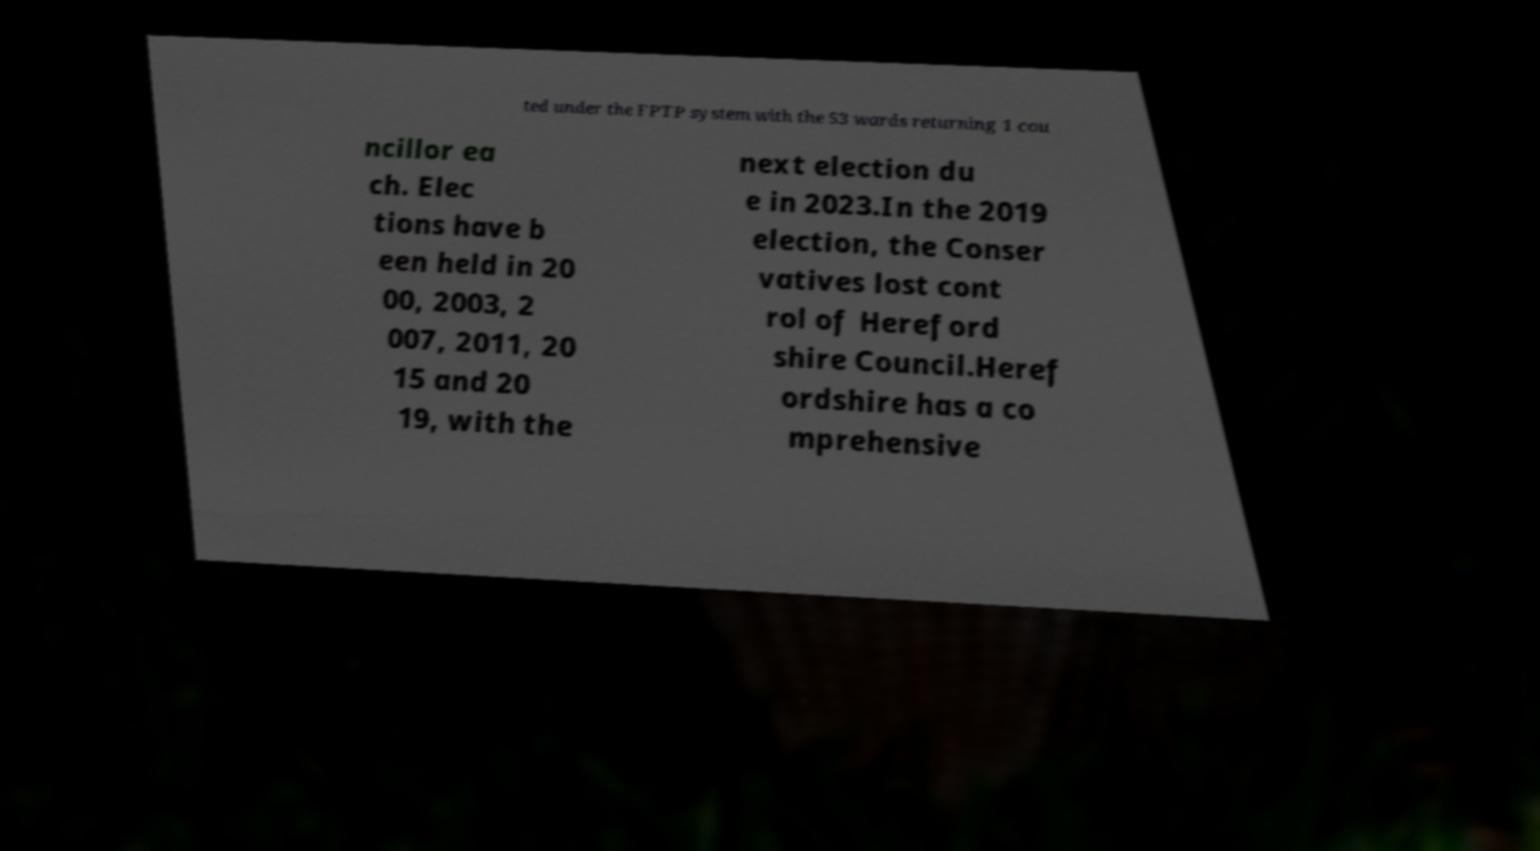Can you read and provide the text displayed in the image?This photo seems to have some interesting text. Can you extract and type it out for me? ted under the FPTP system with the 53 wards returning 1 cou ncillor ea ch. Elec tions have b een held in 20 00, 2003, 2 007, 2011, 20 15 and 20 19, with the next election du e in 2023.In the 2019 election, the Conser vatives lost cont rol of Hereford shire Council.Heref ordshire has a co mprehensive 